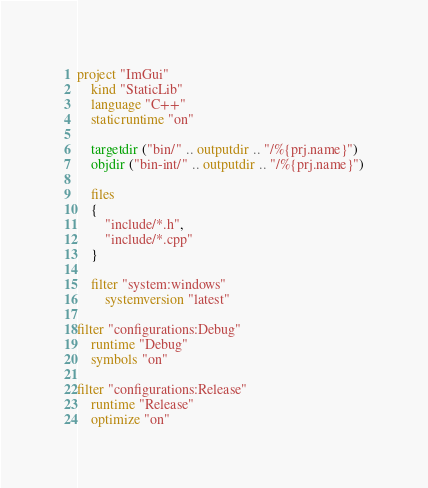<code> <loc_0><loc_0><loc_500><loc_500><_Lua_>project "ImGui"
    kind "StaticLib"
    language "C++"
    staticruntime "on"

    targetdir ("bin/" .. outputdir .. "/%{prj.name}")
    objdir ("bin-int/" .. outputdir .. "/%{prj.name}")

    files
    {
        "include/*.h",
        "include/*.cpp"
    }

    filter "system:windows"
        systemversion "latest"

filter "configurations:Debug"
    runtime "Debug"
    symbols "on"

filter "configurations:Release"
    runtime "Release"
    optimize "on"</code> 